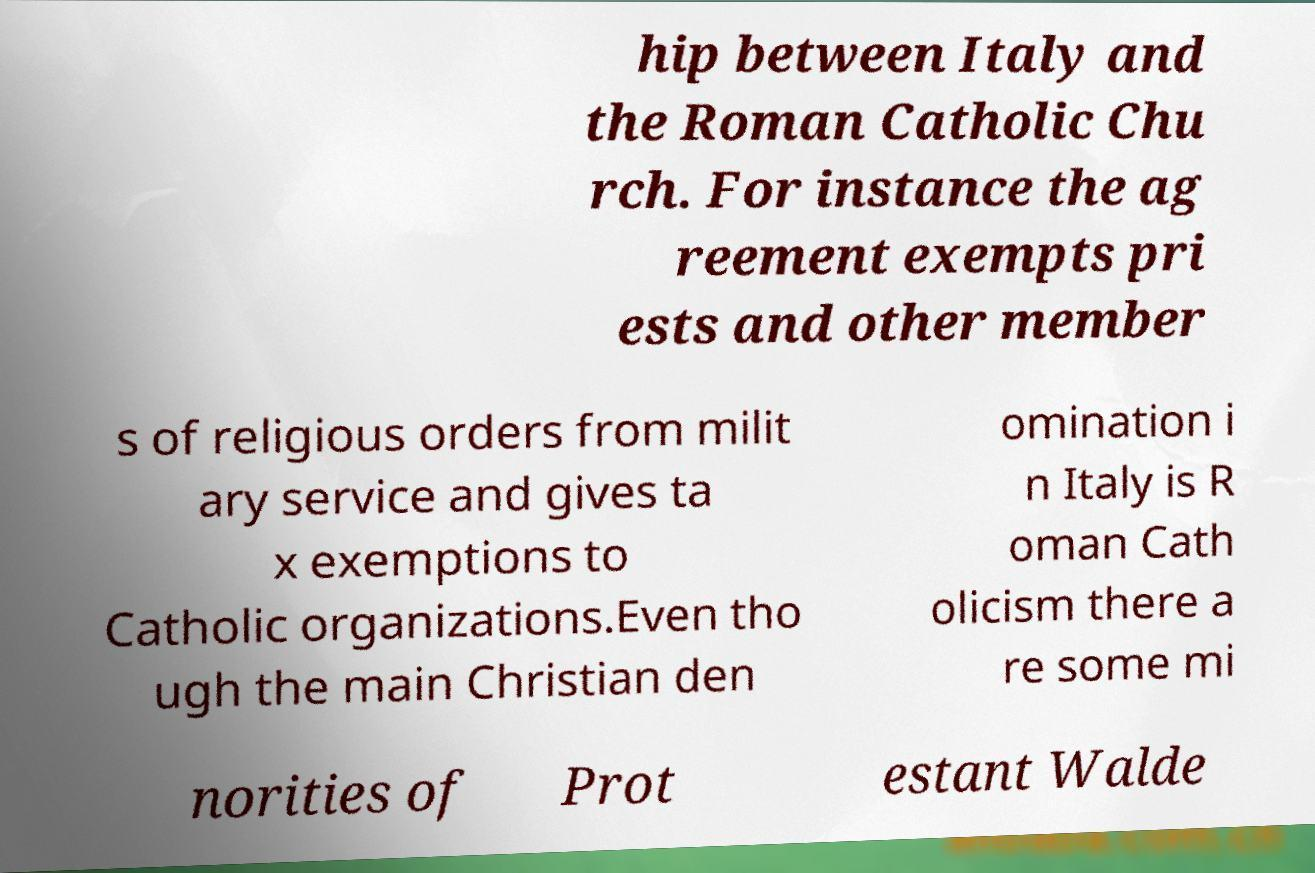I need the written content from this picture converted into text. Can you do that? hip between Italy and the Roman Catholic Chu rch. For instance the ag reement exempts pri ests and other member s of religious orders from milit ary service and gives ta x exemptions to Catholic organizations.Even tho ugh the main Christian den omination i n Italy is R oman Cath olicism there a re some mi norities of Prot estant Walde 